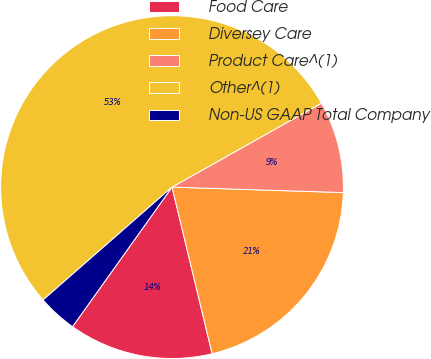Convert chart. <chart><loc_0><loc_0><loc_500><loc_500><pie_chart><fcel>Food Care<fcel>Diversey Care<fcel>Product Care^(1)<fcel>Other^(1)<fcel>Non-US GAAP Total Company<nl><fcel>13.62%<fcel>20.73%<fcel>8.66%<fcel>53.29%<fcel>3.7%<nl></chart> 